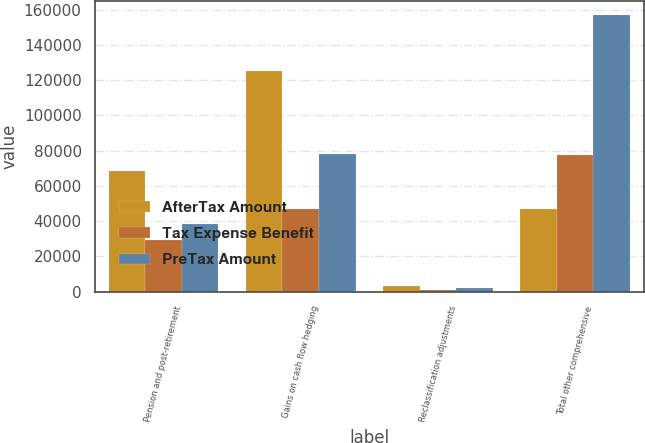<chart> <loc_0><loc_0><loc_500><loc_500><stacked_bar_chart><ecel><fcel>Pension and post-retirement<fcel>Gains on cash flow hedging<fcel>Reclassification adjustments<fcel>Total other comprehensive<nl><fcel>AfterTax Amount<fcel>68217<fcel>125198<fcel>3014<fcel>46941<nl><fcel>Tax Expense Benefit<fcel>29574<fcel>46941<fcel>1152<fcel>77667<nl><fcel>PreTax Amount<fcel>38643<fcel>78257<fcel>1862<fcel>157064<nl></chart> 